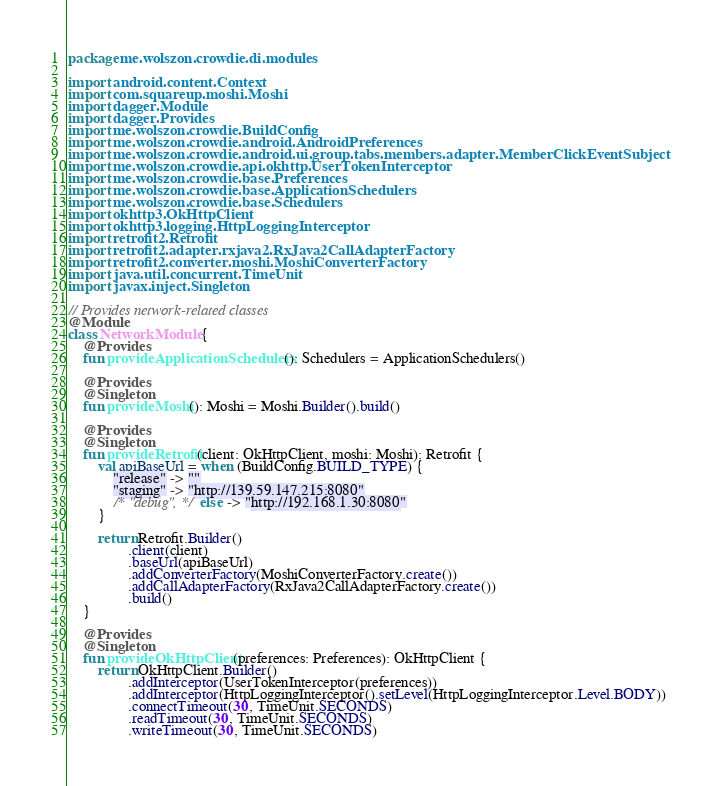<code> <loc_0><loc_0><loc_500><loc_500><_Kotlin_>package me.wolszon.crowdie.di.modules

import android.content.Context
import com.squareup.moshi.Moshi
import dagger.Module
import dagger.Provides
import me.wolszon.crowdie.BuildConfig
import me.wolszon.crowdie.android.AndroidPreferences
import me.wolszon.crowdie.android.ui.group.tabs.members.adapter.MemberClickEventSubject
import me.wolszon.crowdie.api.okhttp.UserTokenInterceptor
import me.wolszon.crowdie.base.Preferences
import me.wolszon.crowdie.base.ApplicationSchedulers
import me.wolszon.crowdie.base.Schedulers
import okhttp3.OkHttpClient
import okhttp3.logging.HttpLoggingInterceptor
import retrofit2.Retrofit
import retrofit2.adapter.rxjava2.RxJava2CallAdapterFactory
import retrofit2.converter.moshi.MoshiConverterFactory
import java.util.concurrent.TimeUnit
import javax.inject.Singleton

// Provides network-related classes
@Module
class NetworkModule {
    @Provides
    fun provideApplicationSchedulers(): Schedulers = ApplicationSchedulers()

    @Provides
    @Singleton
    fun provideMoshi(): Moshi = Moshi.Builder().build()

    @Provides
    @Singleton
    fun provideRetrofit(client: OkHttpClient, moshi: Moshi): Retrofit {
        val apiBaseUrl = when (BuildConfig.BUILD_TYPE) {
            "release" -> ""
            "staging" -> "http://139.59.147.215:8080"
            /* "debug", */ else -> "http://192.168.1.30:8080"
        }

        return Retrofit.Builder()
                .client(client)
                .baseUrl(apiBaseUrl)
                .addConverterFactory(MoshiConverterFactory.create())
                .addCallAdapterFactory(RxJava2CallAdapterFactory.create())
                .build()
    }

    @Provides
    @Singleton
    fun provideOkHttpClient(preferences: Preferences): OkHttpClient {
        return OkHttpClient.Builder()
                .addInterceptor(UserTokenInterceptor(preferences))
                .addInterceptor(HttpLoggingInterceptor().setLevel(HttpLoggingInterceptor.Level.BODY))
                .connectTimeout(30, TimeUnit.SECONDS)
                .readTimeout(30, TimeUnit.SECONDS)
                .writeTimeout(30, TimeUnit.SECONDS)</code> 